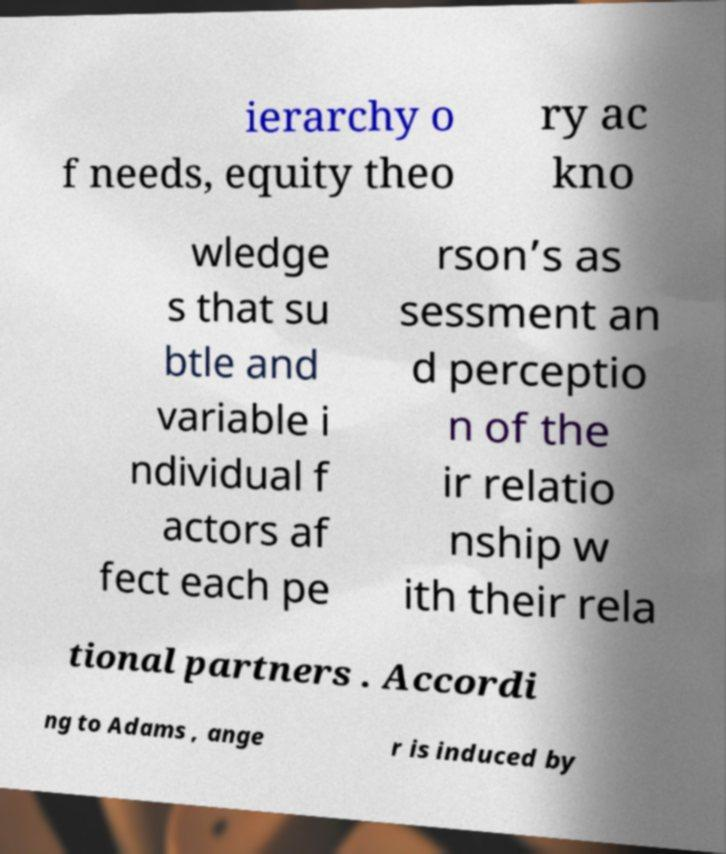Could you assist in decoding the text presented in this image and type it out clearly? ierarchy o f needs, equity theo ry ac kno wledge s that su btle and variable i ndividual f actors af fect each pe rson’s as sessment an d perceptio n of the ir relatio nship w ith their rela tional partners . Accordi ng to Adams , ange r is induced by 